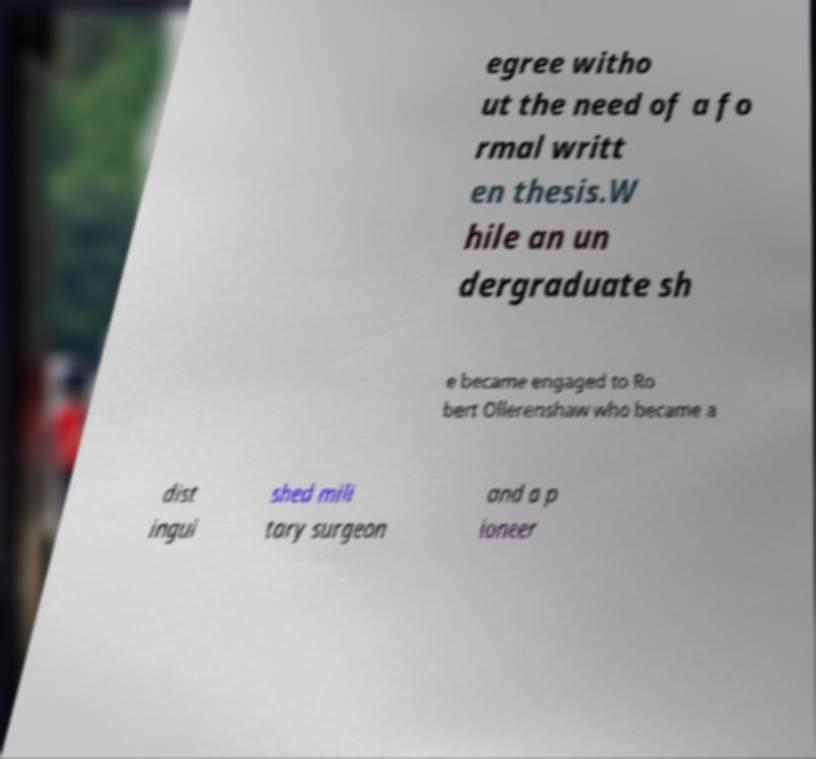There's text embedded in this image that I need extracted. Can you transcribe it verbatim? egree witho ut the need of a fo rmal writt en thesis.W hile an un dergraduate sh e became engaged to Ro bert Ollerenshaw who became a dist ingui shed mili tary surgeon and a p ioneer 